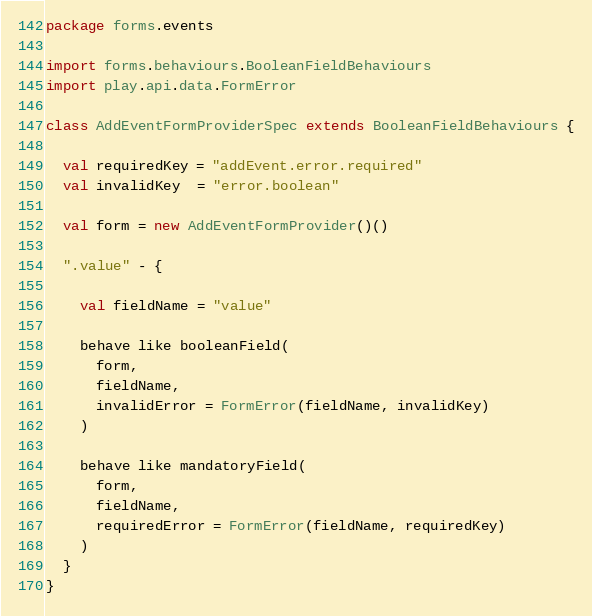Convert code to text. <code><loc_0><loc_0><loc_500><loc_500><_Scala_>
package forms.events

import forms.behaviours.BooleanFieldBehaviours
import play.api.data.FormError

class AddEventFormProviderSpec extends BooleanFieldBehaviours {

  val requiredKey = "addEvent.error.required"
  val invalidKey  = "error.boolean"

  val form = new AddEventFormProvider()()

  ".value" - {

    val fieldName = "value"

    behave like booleanField(
      form,
      fieldName,
      invalidError = FormError(fieldName, invalidKey)
    )

    behave like mandatoryField(
      form,
      fieldName,
      requiredError = FormError(fieldName, requiredKey)
    )
  }
}
</code> 